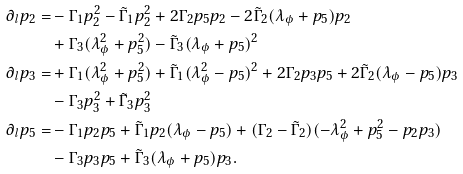<formula> <loc_0><loc_0><loc_500><loc_500>\partial _ { l } p _ { 2 } = & - \Gamma _ { 1 } p _ { 2 } ^ { 2 } - \tilde { \Gamma } _ { 1 } p _ { 2 } ^ { 2 } + 2 \Gamma _ { 2 } p _ { 5 } p _ { 2 } - 2 \tilde { \Gamma } _ { 2 } ( \lambda _ { \phi } + p _ { 5 } ) p _ { 2 } \\ & + \Gamma _ { 3 } ( \lambda _ { \phi } ^ { 2 } + p _ { 5 } ^ { 2 } ) - \tilde { \Gamma } _ { 3 } ( \lambda _ { \phi } + p _ { 5 } ) ^ { 2 } \\ \partial _ { l } p _ { 3 } = & + \Gamma _ { 1 } ( \lambda _ { \phi } ^ { 2 } + p _ { 5 } ^ { 2 } ) + \tilde { \Gamma } _ { 1 } ( \lambda _ { \phi } ^ { 2 } - p _ { 5 } ) ^ { 2 } + 2 \Gamma _ { 2 } p _ { 3 } p _ { 5 } + 2 \tilde { \Gamma } _ { 2 } ( \lambda _ { \phi } - p _ { 5 } ) p _ { 3 } \\ & - \Gamma _ { 3 } p _ { 3 } ^ { 2 } + \tilde { \Gamma } _ { 3 } p _ { 3 } ^ { 2 } \\ \partial _ { l } p _ { 5 } = & - \Gamma _ { 1 } p _ { 2 } p _ { 5 } + \tilde { \Gamma } _ { 1 } p _ { 2 } ( \lambda _ { \phi } - p _ { 5 } ) + ( \Gamma _ { 2 } - \tilde { \Gamma } _ { 2 } ) ( - \lambda _ { \phi } ^ { 2 } + p _ { 5 } ^ { 2 } - p _ { 2 } p _ { 3 } ) \\ & - \Gamma _ { 3 } p _ { 3 } p _ { 5 } + \tilde { \Gamma } _ { 3 } ( \lambda _ { \phi } + p _ { 5 } ) p _ { 3 } .</formula> 